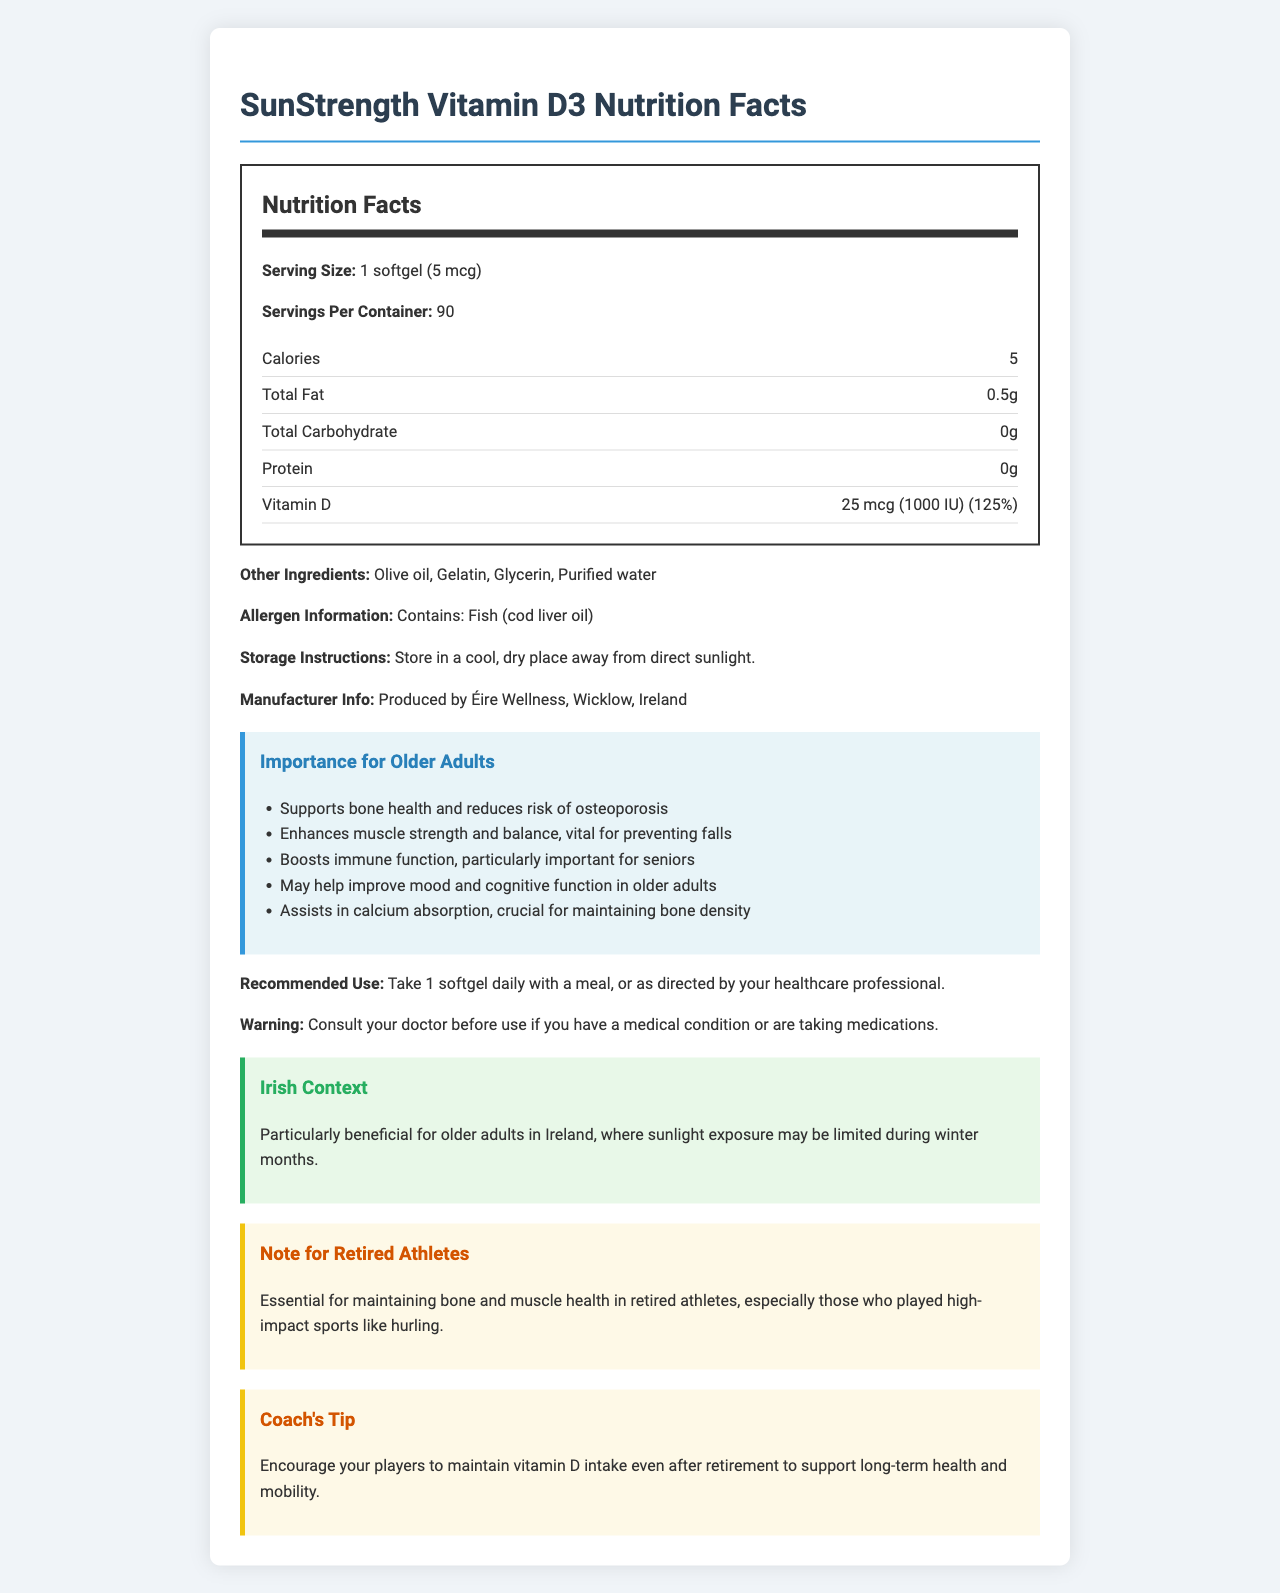what is the product name? The product name is clearly listed at the top of the document.
Answer: SunStrength Vitamin D3 what is the serving size for this supplement? The serving size is given as 1 softgel (5 mcg) in the Nutrition Facts section.
Answer: 1 softgel (5 mcg) how many calories are in one serving? The Nutrition Facts section lists calories per serving as 5.
Answer: 5 calories what additional ingredient might concern someone with a fish allergy? The allergen information section states that the product contains fish (cod liver oil).
Answer: Fish (cod liver oil) how much vitamin D is in each serving, and what percentage of the daily value does it represent? The Nutrition Facts section notes that each serving contains 25 mcg (1000 IU) of Vitamin D, which is 125% of the daily value.
Answer: 25 mcg (1000 IU), 125% Why is this vitamin D supplement particularly beneficial for older adults in Ireland? The Irish Context section explains that older adults in Ireland may have limited sunlight exposure during winter, making a vitamin D supplement particularly beneficial.
Answer: Sunlight exposure may be limited during winter months how much fat is in one softgel? The Nutrition Facts section lists total fat per serving as 0.5g.
Answer: 0.5g what type of oil is included in the supplement's other ingredients? A. Sunflower Oil B. Olive Oil C. Fish Oil D. Soybean Oil The document lists olive oil as one of the other ingredients.
Answer: B what is the recommended use for this supplement? A. Take 2 softgels daily B. Take 1 softgel daily with a meal C. Use as needed D. Take 1 softgel every other day The recommended use is to take 1 softgel daily with a meal.
Answer: B are there any carbohydrate contents listed for this supplement? The Nutrition Facts section lists total carbohydrates per serving as 0g.
Answer: No can this supplement be stored in a warm, humid environment? The storage instructions advise storing in a cool, dry place away from direct sunlight, indicating that a warm, humid environment is not suitable.
Answer: No how should people with existing medical conditions approach the use of this supplement? The warning statement advises consulting a doctor before use if you have a medical condition or are taking medications.
Answer: Consult your doctor before use what are the main benefits of this supplement for older adults? The Importance for Older Adults section lists these main benefits.
Answer: Supports bone health, enhances muscle strength and balance, boosts immune function, improves mood and cognitive function, assists in calcium absorption can vitamin D help improve mood in older adults? One of the listed benefits for older adults is that vitamin D may help improve mood.
Answer: Yes describe the overall document. The document is well-structured with sections on nutrition facts, benefits for older adults, usage instructions, and contextual notes for Irish people and retired athletes.
Answer: The document provides detailed nutrition facts for the SunStrength Vitamin D3 supplement, including its ingredient list, allergen information, storage instructions, and benefits specifically tailored for older adults. It also includes specific notes for older adults in Ireland and retired athletes. who is the manufacturer of this vitamin D supplement? The manufacturer information notes that the supplement is produced by Éire Wellness, Wicklow, Ireland.
Answer: Éire Wellness, Wicklow, Ireland what is the percentage of daily value of Vitamin D provided by one serving of SunStrength Vitamin D3? (a) 50% (b) 75% (c) 100% (d) 125% The Nutrition Facts section states that one serving provides 125% of the daily value for Vitamin D.
Answer: d does this supplement contain any protein? The Nutrition Facts section lists protein per serving as 0g.
Answer: No how long will one container last if following the recommended use? Since there are 90 servings per container and the recommended use is 1 softgel daily, one container will last 90 days.
Answer: 90 days 